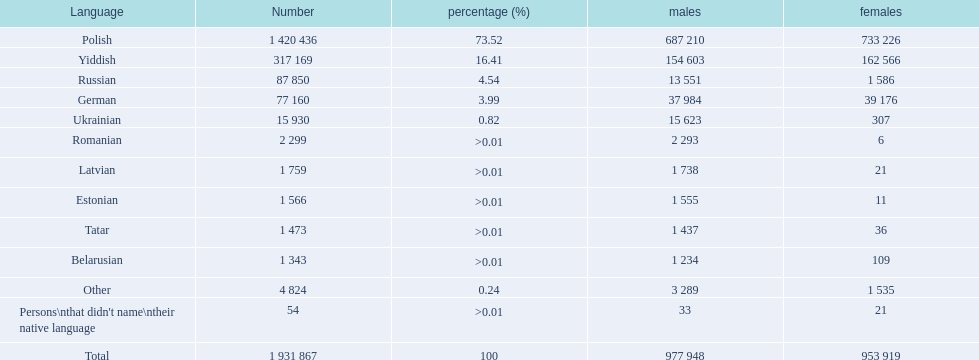In the warsaw governorate, which local languages have more male speakers than female speakers? Russian, Ukrainian, Romanian, Latvian, Estonian, Tatar, Belarusian. Among these, which languages have less than 500 males listed? Romanian, Latvian, Estonian, Tatar, Belarusian. From the remaining languages, which ones have less than 20 females? Romanian, Estonian. Which of these languages has the highest overall number of speakers? Romanian. 